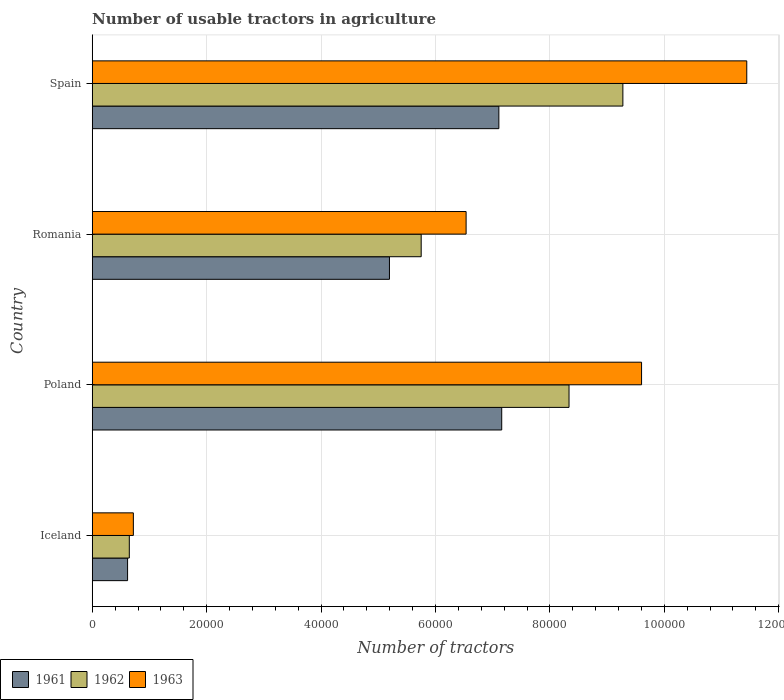How many different coloured bars are there?
Keep it short and to the point. 3. How many groups of bars are there?
Offer a terse response. 4. Are the number of bars on each tick of the Y-axis equal?
Keep it short and to the point. Yes. How many bars are there on the 1st tick from the top?
Give a very brief answer. 3. What is the label of the 3rd group of bars from the top?
Your response must be concise. Poland. In how many cases, is the number of bars for a given country not equal to the number of legend labels?
Give a very brief answer. 0. What is the number of usable tractors in agriculture in 1962 in Spain?
Give a very brief answer. 9.28e+04. Across all countries, what is the maximum number of usable tractors in agriculture in 1962?
Keep it short and to the point. 9.28e+04. Across all countries, what is the minimum number of usable tractors in agriculture in 1962?
Give a very brief answer. 6479. In which country was the number of usable tractors in agriculture in 1961 minimum?
Offer a terse response. Iceland. What is the total number of usable tractors in agriculture in 1961 in the graph?
Make the answer very short. 2.01e+05. What is the difference between the number of usable tractors in agriculture in 1962 in Iceland and that in Spain?
Make the answer very short. -8.63e+04. What is the difference between the number of usable tractors in agriculture in 1961 in Romania and the number of usable tractors in agriculture in 1962 in Iceland?
Your answer should be compact. 4.55e+04. What is the average number of usable tractors in agriculture in 1963 per country?
Keep it short and to the point. 7.07e+04. What is the difference between the number of usable tractors in agriculture in 1963 and number of usable tractors in agriculture in 1962 in Romania?
Give a very brief answer. 7851. In how many countries, is the number of usable tractors in agriculture in 1963 greater than 96000 ?
Offer a terse response. 2. What is the ratio of the number of usable tractors in agriculture in 1963 in Iceland to that in Romania?
Provide a succinct answer. 0.11. Is the difference between the number of usable tractors in agriculture in 1963 in Iceland and Poland greater than the difference between the number of usable tractors in agriculture in 1962 in Iceland and Poland?
Provide a short and direct response. No. What is the difference between the highest and the lowest number of usable tractors in agriculture in 1963?
Your answer should be very brief. 1.07e+05. In how many countries, is the number of usable tractors in agriculture in 1963 greater than the average number of usable tractors in agriculture in 1963 taken over all countries?
Keep it short and to the point. 2. Is it the case that in every country, the sum of the number of usable tractors in agriculture in 1961 and number of usable tractors in agriculture in 1962 is greater than the number of usable tractors in agriculture in 1963?
Offer a terse response. Yes. How many countries are there in the graph?
Keep it short and to the point. 4. What is the difference between two consecutive major ticks on the X-axis?
Provide a succinct answer. 2.00e+04. Where does the legend appear in the graph?
Keep it short and to the point. Bottom left. How are the legend labels stacked?
Provide a succinct answer. Horizontal. What is the title of the graph?
Make the answer very short. Number of usable tractors in agriculture. What is the label or title of the X-axis?
Ensure brevity in your answer.  Number of tractors. What is the Number of tractors of 1961 in Iceland?
Your response must be concise. 6177. What is the Number of tractors in 1962 in Iceland?
Give a very brief answer. 6479. What is the Number of tractors in 1963 in Iceland?
Offer a terse response. 7187. What is the Number of tractors of 1961 in Poland?
Offer a terse response. 7.16e+04. What is the Number of tractors in 1962 in Poland?
Your answer should be very brief. 8.33e+04. What is the Number of tractors in 1963 in Poland?
Make the answer very short. 9.60e+04. What is the Number of tractors of 1961 in Romania?
Your answer should be very brief. 5.20e+04. What is the Number of tractors of 1962 in Romania?
Your answer should be compact. 5.75e+04. What is the Number of tractors in 1963 in Romania?
Your answer should be very brief. 6.54e+04. What is the Number of tractors of 1961 in Spain?
Provide a short and direct response. 7.11e+04. What is the Number of tractors in 1962 in Spain?
Provide a short and direct response. 9.28e+04. What is the Number of tractors in 1963 in Spain?
Offer a very short reply. 1.14e+05. Across all countries, what is the maximum Number of tractors of 1961?
Provide a short and direct response. 7.16e+04. Across all countries, what is the maximum Number of tractors in 1962?
Provide a short and direct response. 9.28e+04. Across all countries, what is the maximum Number of tractors in 1963?
Give a very brief answer. 1.14e+05. Across all countries, what is the minimum Number of tractors of 1961?
Offer a very short reply. 6177. Across all countries, what is the minimum Number of tractors in 1962?
Make the answer very short. 6479. Across all countries, what is the minimum Number of tractors of 1963?
Give a very brief answer. 7187. What is the total Number of tractors of 1961 in the graph?
Your response must be concise. 2.01e+05. What is the total Number of tractors in 1962 in the graph?
Make the answer very short. 2.40e+05. What is the total Number of tractors of 1963 in the graph?
Make the answer very short. 2.83e+05. What is the difference between the Number of tractors in 1961 in Iceland and that in Poland?
Your answer should be very brief. -6.54e+04. What is the difference between the Number of tractors in 1962 in Iceland and that in Poland?
Your answer should be very brief. -7.69e+04. What is the difference between the Number of tractors of 1963 in Iceland and that in Poland?
Offer a very short reply. -8.88e+04. What is the difference between the Number of tractors of 1961 in Iceland and that in Romania?
Make the answer very short. -4.58e+04. What is the difference between the Number of tractors in 1962 in Iceland and that in Romania?
Your answer should be compact. -5.10e+04. What is the difference between the Number of tractors in 1963 in Iceland and that in Romania?
Your answer should be compact. -5.82e+04. What is the difference between the Number of tractors in 1961 in Iceland and that in Spain?
Make the answer very short. -6.49e+04. What is the difference between the Number of tractors in 1962 in Iceland and that in Spain?
Your response must be concise. -8.63e+04. What is the difference between the Number of tractors of 1963 in Iceland and that in Spain?
Your answer should be compact. -1.07e+05. What is the difference between the Number of tractors of 1961 in Poland and that in Romania?
Offer a very short reply. 1.96e+04. What is the difference between the Number of tractors in 1962 in Poland and that in Romania?
Ensure brevity in your answer.  2.58e+04. What is the difference between the Number of tractors of 1963 in Poland and that in Romania?
Provide a succinct answer. 3.07e+04. What is the difference between the Number of tractors of 1961 in Poland and that in Spain?
Your response must be concise. 500. What is the difference between the Number of tractors of 1962 in Poland and that in Spain?
Provide a short and direct response. -9414. What is the difference between the Number of tractors of 1963 in Poland and that in Spain?
Your response must be concise. -1.84e+04. What is the difference between the Number of tractors of 1961 in Romania and that in Spain?
Ensure brevity in your answer.  -1.91e+04. What is the difference between the Number of tractors of 1962 in Romania and that in Spain?
Ensure brevity in your answer.  -3.53e+04. What is the difference between the Number of tractors in 1963 in Romania and that in Spain?
Provide a succinct answer. -4.91e+04. What is the difference between the Number of tractors in 1961 in Iceland and the Number of tractors in 1962 in Poland?
Provide a succinct answer. -7.72e+04. What is the difference between the Number of tractors in 1961 in Iceland and the Number of tractors in 1963 in Poland?
Provide a short and direct response. -8.98e+04. What is the difference between the Number of tractors of 1962 in Iceland and the Number of tractors of 1963 in Poland?
Give a very brief answer. -8.95e+04. What is the difference between the Number of tractors in 1961 in Iceland and the Number of tractors in 1962 in Romania?
Provide a short and direct response. -5.13e+04. What is the difference between the Number of tractors in 1961 in Iceland and the Number of tractors in 1963 in Romania?
Give a very brief answer. -5.92e+04. What is the difference between the Number of tractors in 1962 in Iceland and the Number of tractors in 1963 in Romania?
Make the answer very short. -5.89e+04. What is the difference between the Number of tractors of 1961 in Iceland and the Number of tractors of 1962 in Spain?
Offer a terse response. -8.66e+04. What is the difference between the Number of tractors of 1961 in Iceland and the Number of tractors of 1963 in Spain?
Offer a very short reply. -1.08e+05. What is the difference between the Number of tractors in 1962 in Iceland and the Number of tractors in 1963 in Spain?
Your answer should be very brief. -1.08e+05. What is the difference between the Number of tractors in 1961 in Poland and the Number of tractors in 1962 in Romania?
Provide a short and direct response. 1.41e+04. What is the difference between the Number of tractors of 1961 in Poland and the Number of tractors of 1963 in Romania?
Your answer should be very brief. 6226. What is the difference between the Number of tractors of 1962 in Poland and the Number of tractors of 1963 in Romania?
Ensure brevity in your answer.  1.80e+04. What is the difference between the Number of tractors of 1961 in Poland and the Number of tractors of 1962 in Spain?
Ensure brevity in your answer.  -2.12e+04. What is the difference between the Number of tractors in 1961 in Poland and the Number of tractors in 1963 in Spain?
Make the answer very short. -4.28e+04. What is the difference between the Number of tractors in 1962 in Poland and the Number of tractors in 1963 in Spain?
Your answer should be very brief. -3.11e+04. What is the difference between the Number of tractors of 1961 in Romania and the Number of tractors of 1962 in Spain?
Ensure brevity in your answer.  -4.08e+04. What is the difference between the Number of tractors in 1961 in Romania and the Number of tractors in 1963 in Spain?
Your answer should be very brief. -6.25e+04. What is the difference between the Number of tractors of 1962 in Romania and the Number of tractors of 1963 in Spain?
Your answer should be compact. -5.69e+04. What is the average Number of tractors of 1961 per country?
Offer a terse response. 5.02e+04. What is the average Number of tractors in 1962 per country?
Give a very brief answer. 6.00e+04. What is the average Number of tractors in 1963 per country?
Provide a short and direct response. 7.07e+04. What is the difference between the Number of tractors of 1961 and Number of tractors of 1962 in Iceland?
Make the answer very short. -302. What is the difference between the Number of tractors of 1961 and Number of tractors of 1963 in Iceland?
Offer a very short reply. -1010. What is the difference between the Number of tractors of 1962 and Number of tractors of 1963 in Iceland?
Your response must be concise. -708. What is the difference between the Number of tractors in 1961 and Number of tractors in 1962 in Poland?
Keep it short and to the point. -1.18e+04. What is the difference between the Number of tractors in 1961 and Number of tractors in 1963 in Poland?
Make the answer very short. -2.44e+04. What is the difference between the Number of tractors of 1962 and Number of tractors of 1963 in Poland?
Provide a succinct answer. -1.27e+04. What is the difference between the Number of tractors of 1961 and Number of tractors of 1962 in Romania?
Your answer should be very brief. -5548. What is the difference between the Number of tractors in 1961 and Number of tractors in 1963 in Romania?
Offer a very short reply. -1.34e+04. What is the difference between the Number of tractors of 1962 and Number of tractors of 1963 in Romania?
Your response must be concise. -7851. What is the difference between the Number of tractors in 1961 and Number of tractors in 1962 in Spain?
Your response must be concise. -2.17e+04. What is the difference between the Number of tractors in 1961 and Number of tractors in 1963 in Spain?
Give a very brief answer. -4.33e+04. What is the difference between the Number of tractors of 1962 and Number of tractors of 1963 in Spain?
Your answer should be very brief. -2.17e+04. What is the ratio of the Number of tractors of 1961 in Iceland to that in Poland?
Offer a terse response. 0.09. What is the ratio of the Number of tractors in 1962 in Iceland to that in Poland?
Offer a very short reply. 0.08. What is the ratio of the Number of tractors in 1963 in Iceland to that in Poland?
Your answer should be very brief. 0.07. What is the ratio of the Number of tractors in 1961 in Iceland to that in Romania?
Give a very brief answer. 0.12. What is the ratio of the Number of tractors of 1962 in Iceland to that in Romania?
Provide a short and direct response. 0.11. What is the ratio of the Number of tractors of 1963 in Iceland to that in Romania?
Offer a very short reply. 0.11. What is the ratio of the Number of tractors of 1961 in Iceland to that in Spain?
Offer a terse response. 0.09. What is the ratio of the Number of tractors in 1962 in Iceland to that in Spain?
Your answer should be very brief. 0.07. What is the ratio of the Number of tractors of 1963 in Iceland to that in Spain?
Offer a terse response. 0.06. What is the ratio of the Number of tractors in 1961 in Poland to that in Romania?
Provide a short and direct response. 1.38. What is the ratio of the Number of tractors of 1962 in Poland to that in Romania?
Your response must be concise. 1.45. What is the ratio of the Number of tractors in 1963 in Poland to that in Romania?
Your answer should be very brief. 1.47. What is the ratio of the Number of tractors in 1962 in Poland to that in Spain?
Your response must be concise. 0.9. What is the ratio of the Number of tractors in 1963 in Poland to that in Spain?
Your answer should be very brief. 0.84. What is the ratio of the Number of tractors in 1961 in Romania to that in Spain?
Keep it short and to the point. 0.73. What is the ratio of the Number of tractors in 1962 in Romania to that in Spain?
Offer a very short reply. 0.62. What is the ratio of the Number of tractors of 1963 in Romania to that in Spain?
Your answer should be compact. 0.57. What is the difference between the highest and the second highest Number of tractors of 1961?
Keep it short and to the point. 500. What is the difference between the highest and the second highest Number of tractors in 1962?
Ensure brevity in your answer.  9414. What is the difference between the highest and the second highest Number of tractors in 1963?
Offer a very short reply. 1.84e+04. What is the difference between the highest and the lowest Number of tractors of 1961?
Give a very brief answer. 6.54e+04. What is the difference between the highest and the lowest Number of tractors in 1962?
Give a very brief answer. 8.63e+04. What is the difference between the highest and the lowest Number of tractors of 1963?
Keep it short and to the point. 1.07e+05. 